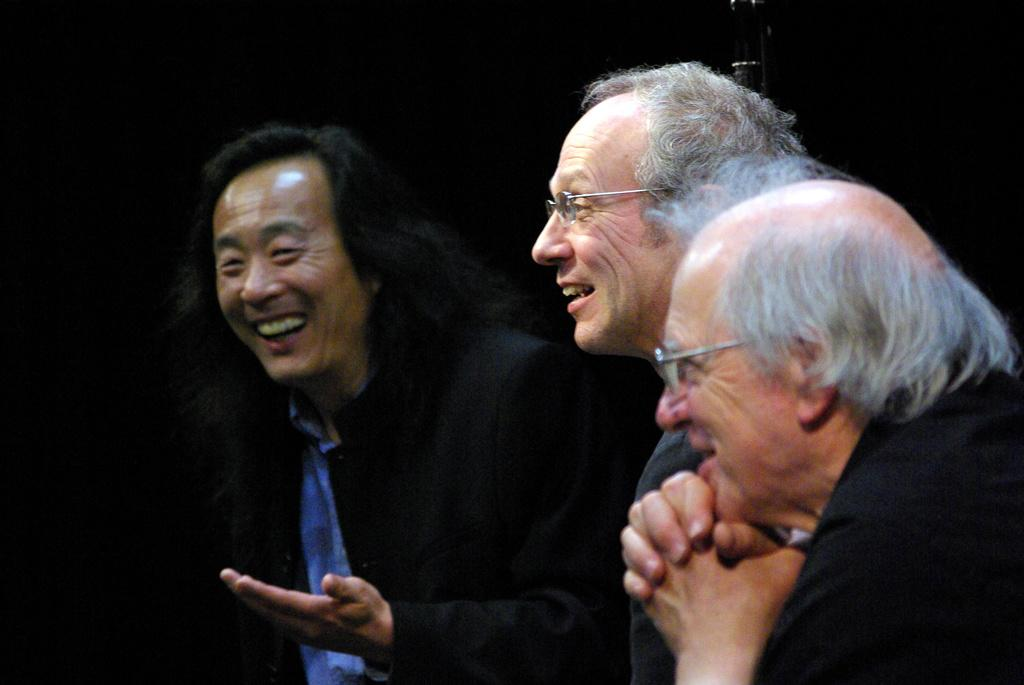How many people are in the image? There are people in the image, but the exact number is not specified. What object can be seen in the image? There is an object in the image, but its description is not provided. What is the color of the background in the image? The background of the image is dark. What is the name of the game being played by the people in the image? There is no indication of a game being played in the image, so it is not possible to determine the name of the game. 